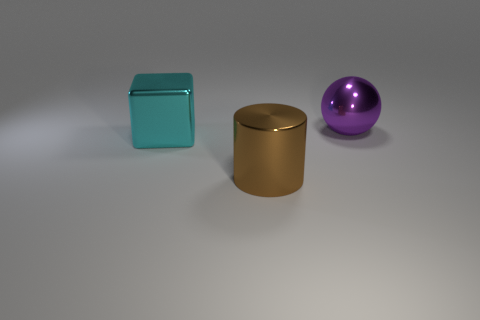Is there anything else that is the same size as the purple shiny thing?
Ensure brevity in your answer.  Yes. What number of objects are large cyan matte balls or large shiny objects?
Provide a succinct answer. 3. Are there any other cyan cubes of the same size as the cyan cube?
Your answer should be compact. No. What is the shape of the big brown object?
Offer a very short reply. Cylinder. Is the number of brown shiny objects that are behind the purple shiny thing greater than the number of metallic cylinders that are left of the cyan metal object?
Your response must be concise. No. There is a large metallic object that is right of the brown metallic cylinder; is it the same color as the large metal object in front of the large cube?
Your answer should be compact. No. There is a brown thing that is the same size as the purple metallic sphere; what is its shape?
Ensure brevity in your answer.  Cylinder. Is there another purple thing that has the same shape as the big purple object?
Your answer should be compact. No. Is the big object on the right side of the big brown metal thing made of the same material as the thing that is on the left side of the large brown shiny cylinder?
Make the answer very short. Yes. How many large cyan cubes have the same material as the large purple thing?
Your response must be concise. 1. 